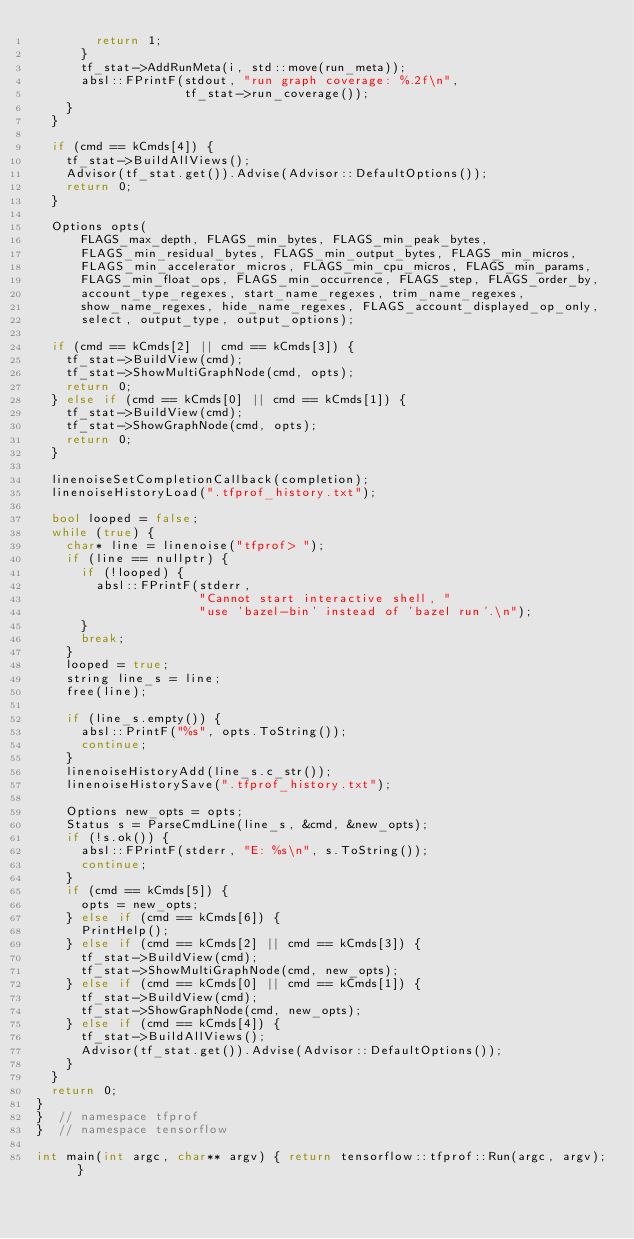<code> <loc_0><loc_0><loc_500><loc_500><_C++_>        return 1;
      }
      tf_stat->AddRunMeta(i, std::move(run_meta));
      absl::FPrintF(stdout, "run graph coverage: %.2f\n",
                    tf_stat->run_coverage());
    }
  }

  if (cmd == kCmds[4]) {
    tf_stat->BuildAllViews();
    Advisor(tf_stat.get()).Advise(Advisor::DefaultOptions());
    return 0;
  }

  Options opts(
      FLAGS_max_depth, FLAGS_min_bytes, FLAGS_min_peak_bytes,
      FLAGS_min_residual_bytes, FLAGS_min_output_bytes, FLAGS_min_micros,
      FLAGS_min_accelerator_micros, FLAGS_min_cpu_micros, FLAGS_min_params,
      FLAGS_min_float_ops, FLAGS_min_occurrence, FLAGS_step, FLAGS_order_by,
      account_type_regexes, start_name_regexes, trim_name_regexes,
      show_name_regexes, hide_name_regexes, FLAGS_account_displayed_op_only,
      select, output_type, output_options);

  if (cmd == kCmds[2] || cmd == kCmds[3]) {
    tf_stat->BuildView(cmd);
    tf_stat->ShowMultiGraphNode(cmd, opts);
    return 0;
  } else if (cmd == kCmds[0] || cmd == kCmds[1]) {
    tf_stat->BuildView(cmd);
    tf_stat->ShowGraphNode(cmd, opts);
    return 0;
  }

  linenoiseSetCompletionCallback(completion);
  linenoiseHistoryLoad(".tfprof_history.txt");

  bool looped = false;
  while (true) {
    char* line = linenoise("tfprof> ");
    if (line == nullptr) {
      if (!looped) {
        absl::FPrintF(stderr,
                      "Cannot start interactive shell, "
                      "use 'bazel-bin' instead of 'bazel run'.\n");
      }
      break;
    }
    looped = true;
    string line_s = line;
    free(line);

    if (line_s.empty()) {
      absl::PrintF("%s", opts.ToString());
      continue;
    }
    linenoiseHistoryAdd(line_s.c_str());
    linenoiseHistorySave(".tfprof_history.txt");

    Options new_opts = opts;
    Status s = ParseCmdLine(line_s, &cmd, &new_opts);
    if (!s.ok()) {
      absl::FPrintF(stderr, "E: %s\n", s.ToString());
      continue;
    }
    if (cmd == kCmds[5]) {
      opts = new_opts;
    } else if (cmd == kCmds[6]) {
      PrintHelp();
    } else if (cmd == kCmds[2] || cmd == kCmds[3]) {
      tf_stat->BuildView(cmd);
      tf_stat->ShowMultiGraphNode(cmd, new_opts);
    } else if (cmd == kCmds[0] || cmd == kCmds[1]) {
      tf_stat->BuildView(cmd);
      tf_stat->ShowGraphNode(cmd, new_opts);
    } else if (cmd == kCmds[4]) {
      tf_stat->BuildAllViews();
      Advisor(tf_stat.get()).Advise(Advisor::DefaultOptions());
    }
  }
  return 0;
}
}  // namespace tfprof
}  // namespace tensorflow

int main(int argc, char** argv) { return tensorflow::tfprof::Run(argc, argv); }
</code> 